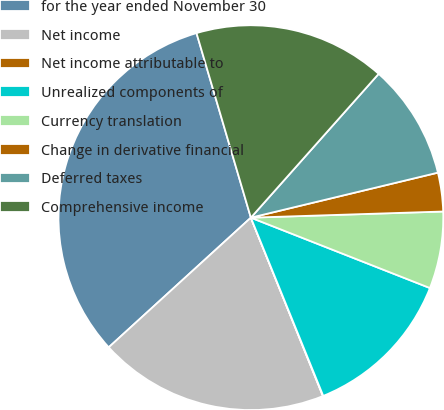Convert chart. <chart><loc_0><loc_0><loc_500><loc_500><pie_chart><fcel>for the year ended November 30<fcel>Net income<fcel>Net income attributable to<fcel>Unrealized components of<fcel>Currency translation<fcel>Change in derivative financial<fcel>Deferred taxes<fcel>Comprehensive income<nl><fcel>32.21%<fcel>19.34%<fcel>0.03%<fcel>12.9%<fcel>6.47%<fcel>3.25%<fcel>9.68%<fcel>16.12%<nl></chart> 